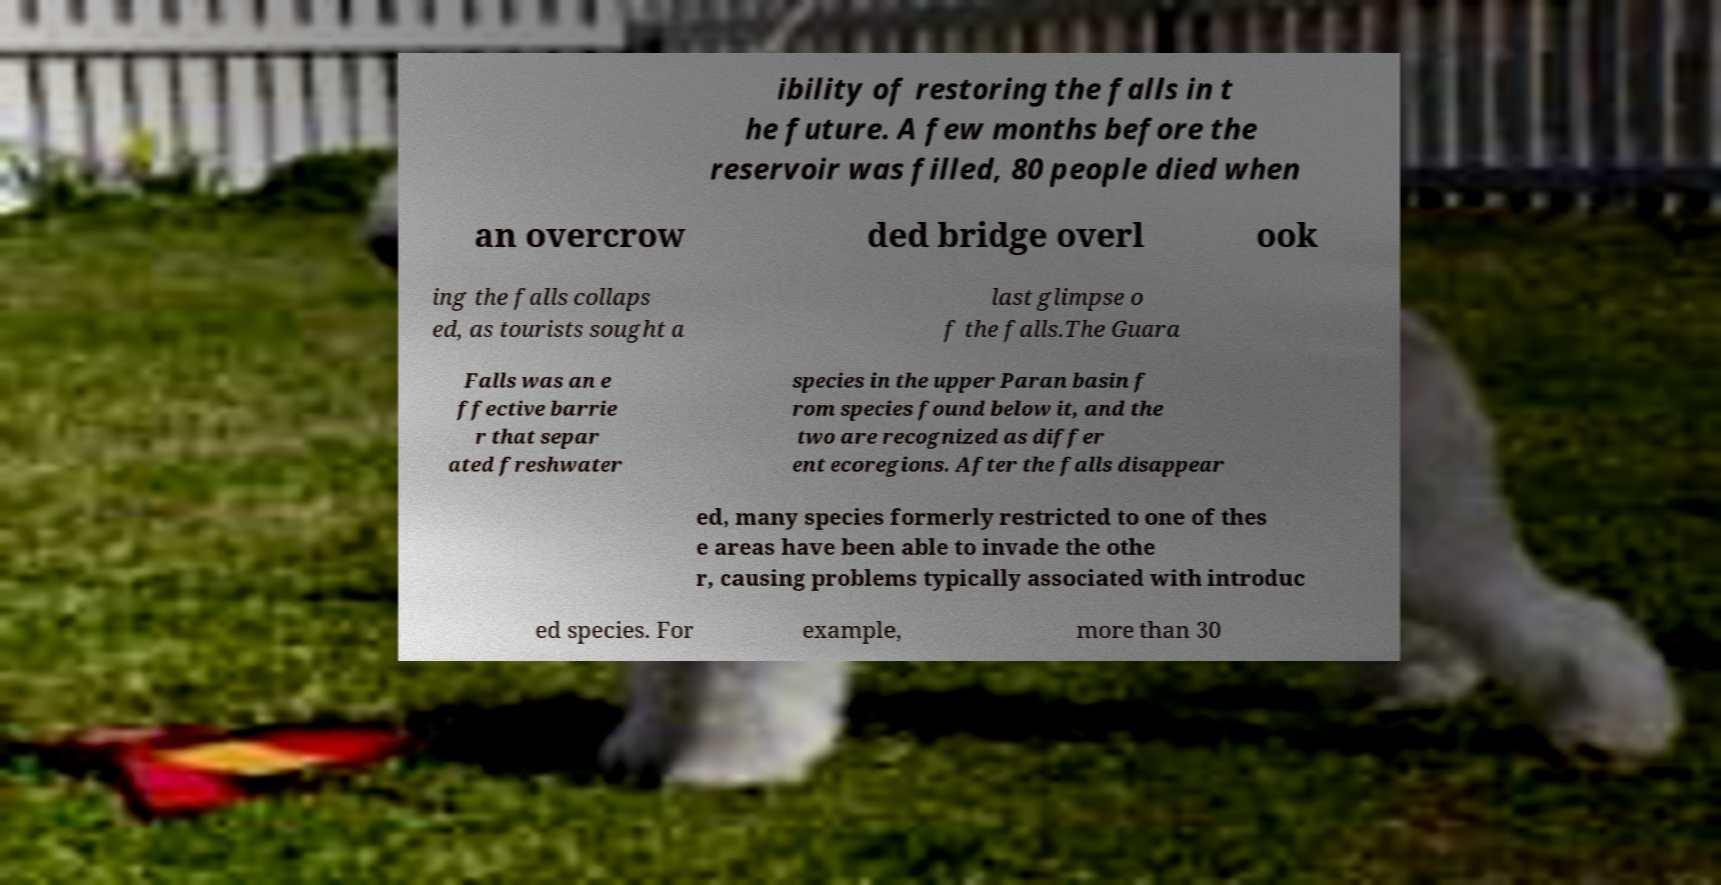Could you assist in decoding the text presented in this image and type it out clearly? ibility of restoring the falls in t he future. A few months before the reservoir was filled, 80 people died when an overcrow ded bridge overl ook ing the falls collaps ed, as tourists sought a last glimpse o f the falls.The Guara Falls was an e ffective barrie r that separ ated freshwater species in the upper Paran basin f rom species found below it, and the two are recognized as differ ent ecoregions. After the falls disappear ed, many species formerly restricted to one of thes e areas have been able to invade the othe r, causing problems typically associated with introduc ed species. For example, more than 30 